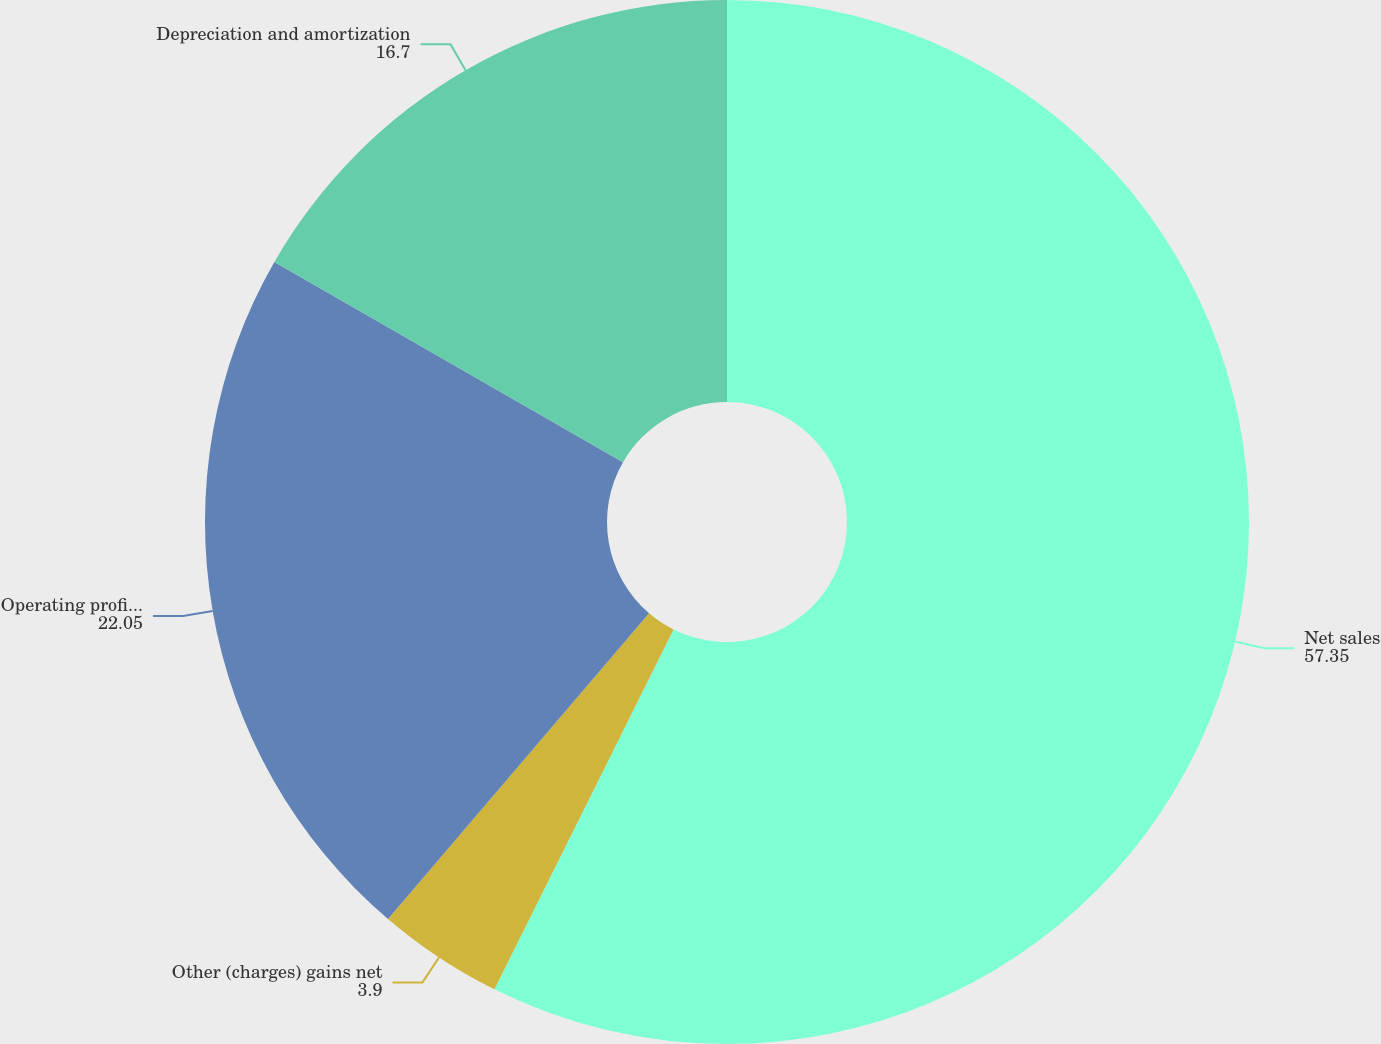Convert chart. <chart><loc_0><loc_0><loc_500><loc_500><pie_chart><fcel>Net sales<fcel>Other (charges) gains net<fcel>Operating profit (loss)<fcel>Depreciation and amortization<nl><fcel>57.35%<fcel>3.9%<fcel>22.05%<fcel>16.7%<nl></chart> 